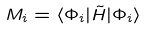<formula> <loc_0><loc_0><loc_500><loc_500>M _ { i } = \langle \Phi _ { i } | \tilde { H } | \Phi _ { i } \rangle</formula> 